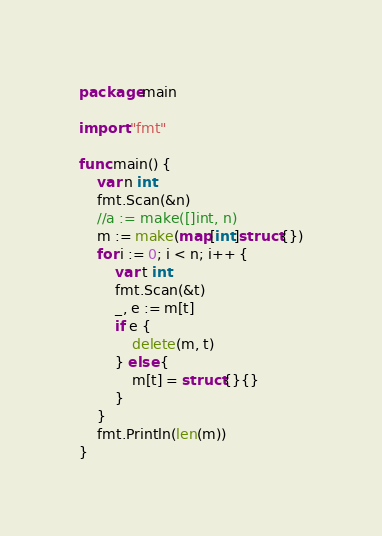Convert code to text. <code><loc_0><loc_0><loc_500><loc_500><_Go_>package main

import "fmt"

func main() {
	var n int
	fmt.Scan(&n)
	//a := make([]int, n)
	m := make(map[int]struct{})
	for i := 0; i < n; i++ {
		var t int
		fmt.Scan(&t)
		_, e := m[t]
		if e {
			delete(m, t)
		} else {
			m[t] = struct{}{}
		}
	}
	fmt.Println(len(m))
}
</code> 